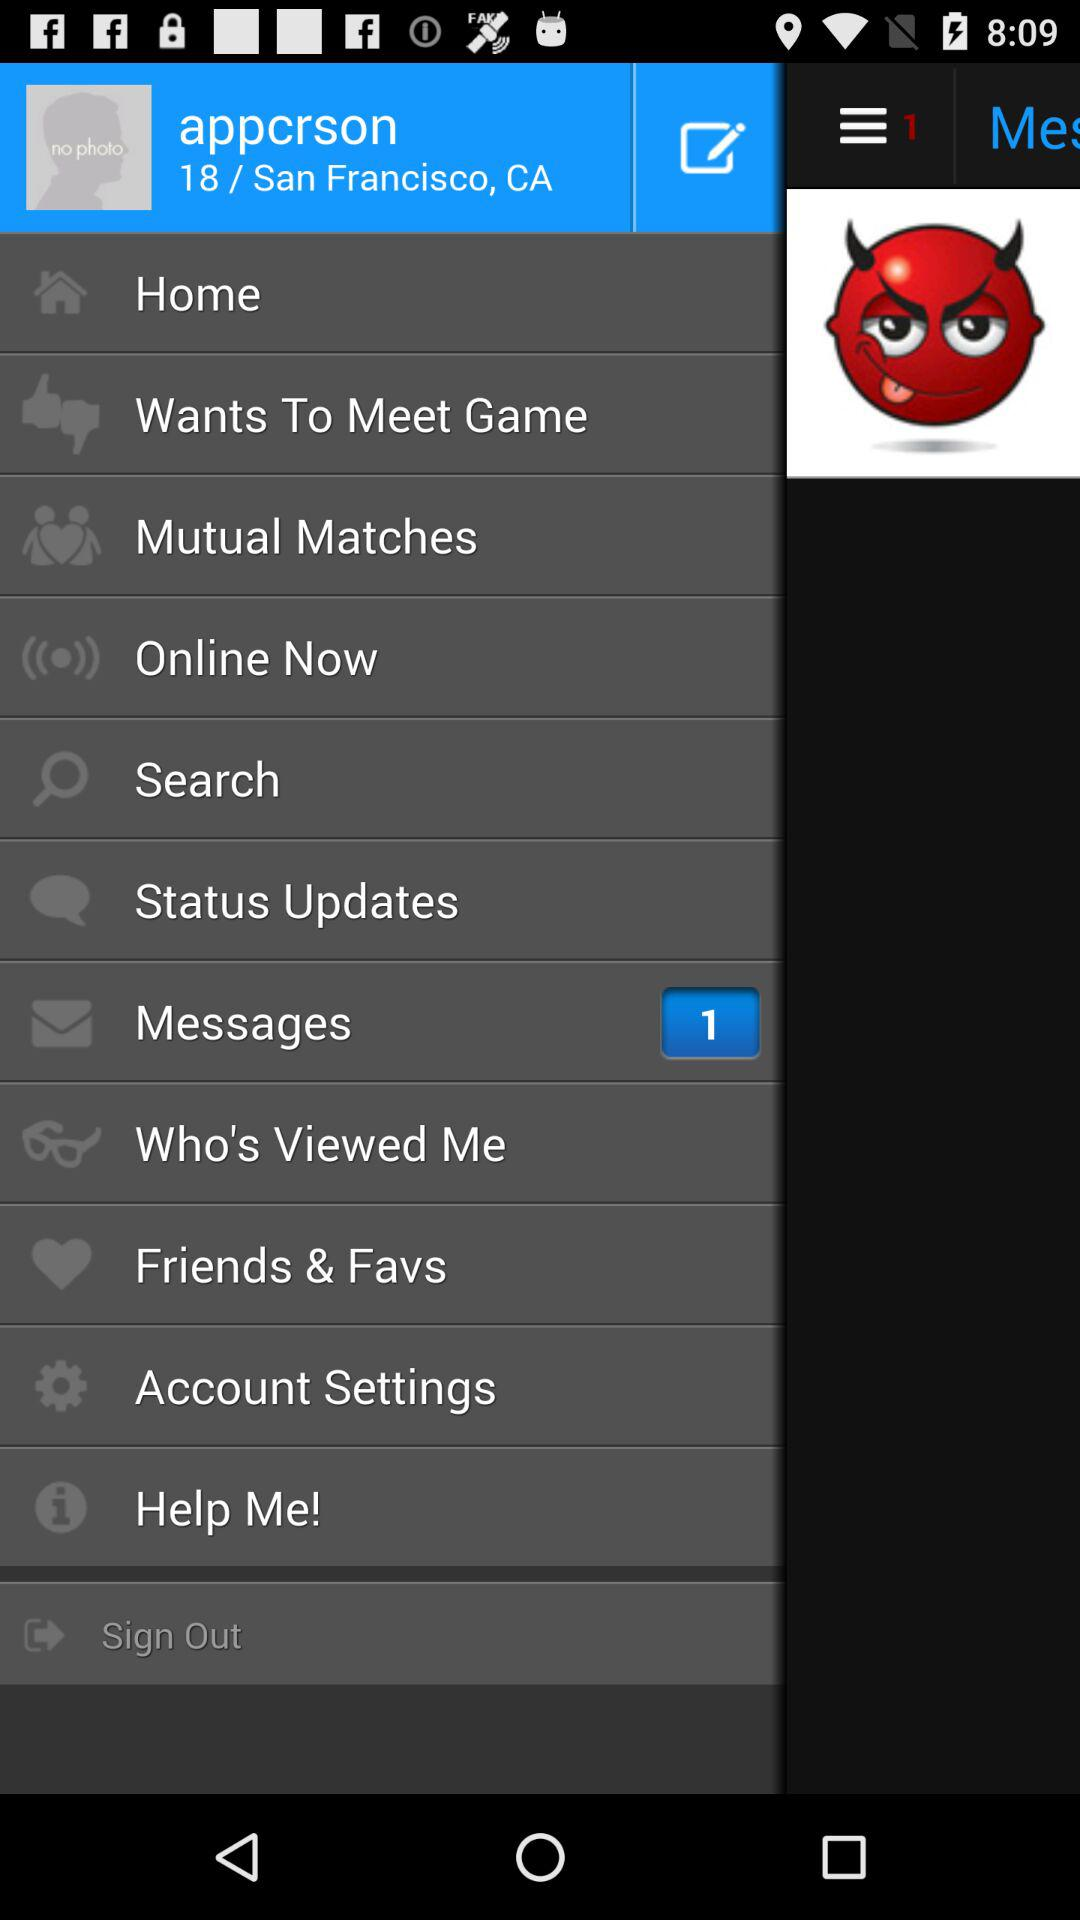What is the age of the user? The age of the user is 18. 